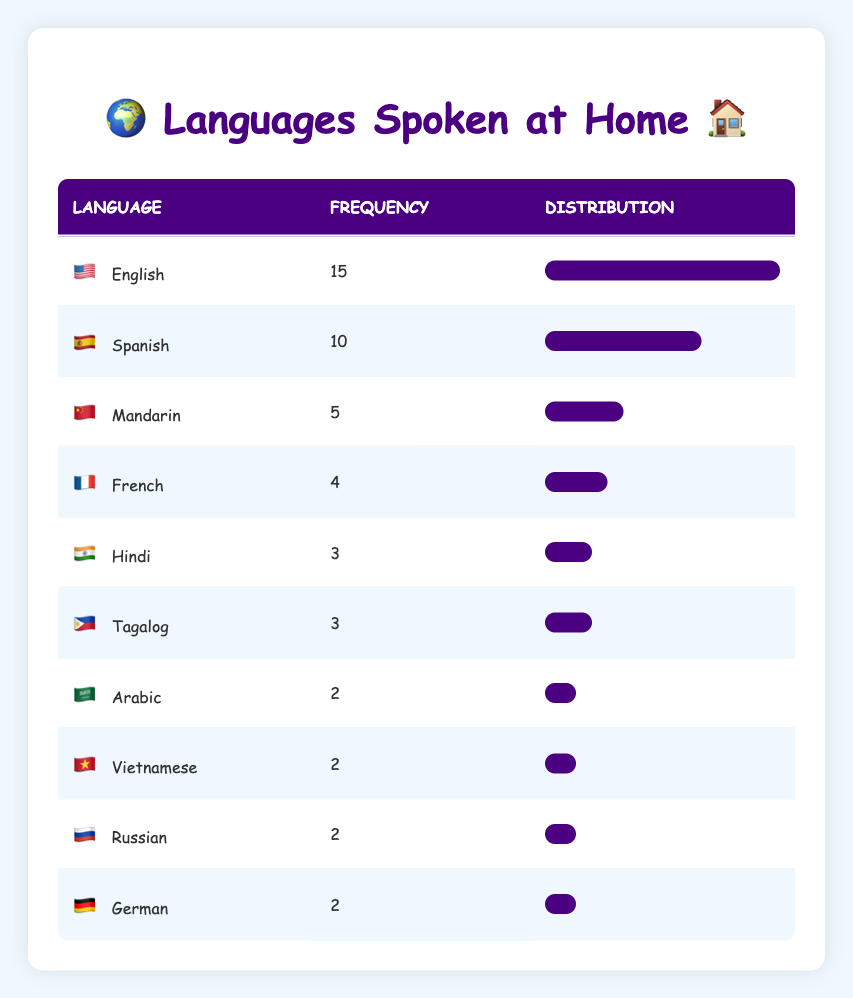What is the frequency of students who speak Spanish at home? According to the table, the frequency for Spanish is directly shown as 10.
Answer: 10 Which language is spoken at home by the most students? The language with the highest frequency is English, which is spoken by 15 students.
Answer: English How many languages have a frequency of 2? The table shows that there are four languages (Arabic, Vietnamese, Russian, German) each with a frequency of 2.
Answer: 4 What is the total number of students represented in the table? To find the total, add all the frequencies: 15 + 10 + 5 + 4 + 3 + 2 + 3 + 2 + 2 + 2 = 54.
Answer: 54 Is the frequency of French greater than the frequency of Hindi? The frequency for French is 4 and for Hindi is 3, thus French has a greater frequency.
Answer: Yes What percentage of the total students speak Mandarin? The frequency for Mandarin is 5. To calculate the percentage: (5/54) * 100 ≈ 9.26%.
Answer: Approximately 9.26% Which language has the second highest number of speakers at home? After English, Spanish has the second highest frequency of 10.
Answer: Spanish If we combine the frequencies of Hindi and Tagalog, how many students will that be? The frequency for Hindi is 3 and for Tagalog is also 3. Adding these gives 3 + 3 = 6.
Answer: 6 What is the difference in frequency between the languages with the highest and lowest numbers spoken at home? The highest frequency is for English (15) and the lowest is for Arabic, Vietnamese, Russian, and German (all with 2). The difference is 15 - 2 = 13.
Answer: 13 